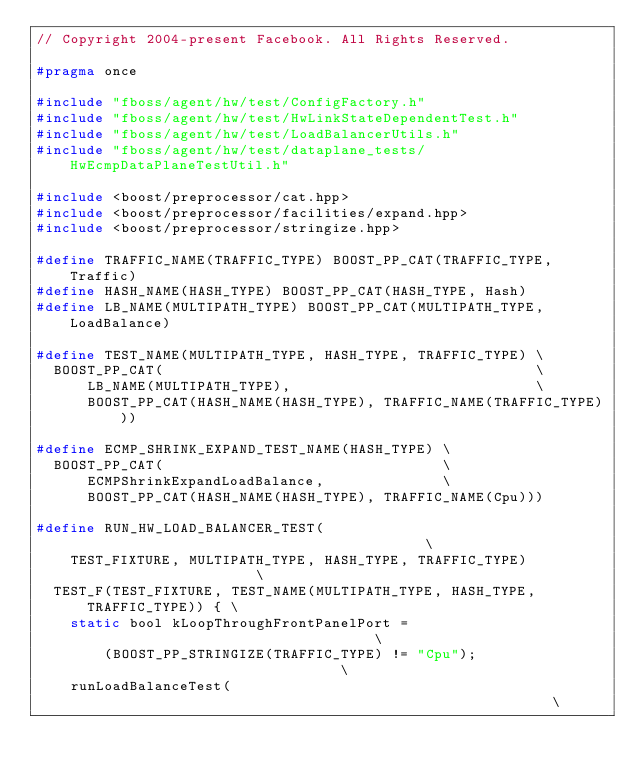Convert code to text. <code><loc_0><loc_0><loc_500><loc_500><_C_>// Copyright 2004-present Facebook. All Rights Reserved.

#pragma once

#include "fboss/agent/hw/test/ConfigFactory.h"
#include "fboss/agent/hw/test/HwLinkStateDependentTest.h"
#include "fboss/agent/hw/test/LoadBalancerUtils.h"
#include "fboss/agent/hw/test/dataplane_tests/HwEcmpDataPlaneTestUtil.h"

#include <boost/preprocessor/cat.hpp>
#include <boost/preprocessor/facilities/expand.hpp>
#include <boost/preprocessor/stringize.hpp>

#define TRAFFIC_NAME(TRAFFIC_TYPE) BOOST_PP_CAT(TRAFFIC_TYPE, Traffic)
#define HASH_NAME(HASH_TYPE) BOOST_PP_CAT(HASH_TYPE, Hash)
#define LB_NAME(MULTIPATH_TYPE) BOOST_PP_CAT(MULTIPATH_TYPE, LoadBalance)

#define TEST_NAME(MULTIPATH_TYPE, HASH_TYPE, TRAFFIC_TYPE) \
  BOOST_PP_CAT(                                            \
      LB_NAME(MULTIPATH_TYPE),                             \
      BOOST_PP_CAT(HASH_NAME(HASH_TYPE), TRAFFIC_NAME(TRAFFIC_TYPE)))

#define ECMP_SHRINK_EXPAND_TEST_NAME(HASH_TYPE) \
  BOOST_PP_CAT(                                 \
      ECMPShrinkExpandLoadBalance,              \
      BOOST_PP_CAT(HASH_NAME(HASH_TYPE), TRAFFIC_NAME(Cpu)))

#define RUN_HW_LOAD_BALANCER_TEST(                                           \
    TEST_FIXTURE, MULTIPATH_TYPE, HASH_TYPE, TRAFFIC_TYPE)                   \
  TEST_F(TEST_FIXTURE, TEST_NAME(MULTIPATH_TYPE, HASH_TYPE, TRAFFIC_TYPE)) { \
    static bool kLoopThroughFrontPanelPort =                                 \
        (BOOST_PP_STRINGIZE(TRAFFIC_TYPE) != "Cpu");                         \
    runLoadBalanceTest(                                                      \</code> 